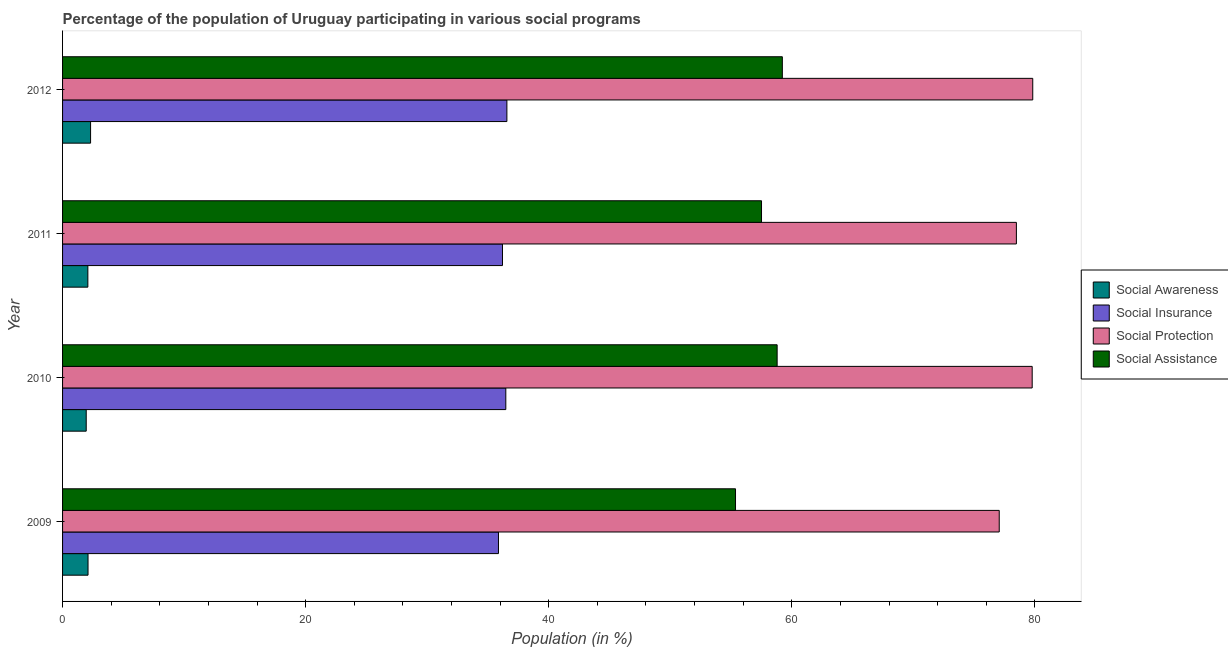How many different coloured bars are there?
Provide a short and direct response. 4. Are the number of bars per tick equal to the number of legend labels?
Your answer should be compact. Yes. In how many cases, is the number of bars for a given year not equal to the number of legend labels?
Make the answer very short. 0. What is the participation of population in social protection programs in 2009?
Offer a terse response. 77.07. Across all years, what is the maximum participation of population in social awareness programs?
Ensure brevity in your answer.  2.31. Across all years, what is the minimum participation of population in social assistance programs?
Make the answer very short. 55.37. In which year was the participation of population in social insurance programs minimum?
Provide a short and direct response. 2009. What is the total participation of population in social protection programs in the graph?
Offer a terse response. 315.14. What is the difference between the participation of population in social insurance programs in 2009 and that in 2012?
Provide a succinct answer. -0.69. What is the difference between the participation of population in social awareness programs in 2010 and the participation of population in social protection programs in 2009?
Offer a terse response. -75.12. What is the average participation of population in social protection programs per year?
Keep it short and to the point. 78.79. In the year 2011, what is the difference between the participation of population in social assistance programs and participation of population in social insurance programs?
Offer a very short reply. 21.31. What is the ratio of the participation of population in social insurance programs in 2009 to that in 2012?
Provide a succinct answer. 0.98. Is the participation of population in social assistance programs in 2010 less than that in 2012?
Give a very brief answer. Yes. What is the difference between the highest and the second highest participation of population in social insurance programs?
Your answer should be compact. 0.09. What is the difference between the highest and the lowest participation of population in social assistance programs?
Your answer should be very brief. 3.85. What does the 2nd bar from the top in 2011 represents?
Your answer should be compact. Social Protection. What does the 3rd bar from the bottom in 2010 represents?
Provide a short and direct response. Social Protection. Is it the case that in every year, the sum of the participation of population in social awareness programs and participation of population in social insurance programs is greater than the participation of population in social protection programs?
Make the answer very short. No. How many years are there in the graph?
Provide a short and direct response. 4. What is the difference between two consecutive major ticks on the X-axis?
Give a very brief answer. 20. Where does the legend appear in the graph?
Your answer should be very brief. Center right. What is the title of the graph?
Ensure brevity in your answer.  Percentage of the population of Uruguay participating in various social programs . Does "Tertiary education" appear as one of the legend labels in the graph?
Make the answer very short. No. What is the label or title of the X-axis?
Provide a succinct answer. Population (in %). What is the label or title of the Y-axis?
Your response must be concise. Year. What is the Population (in %) in Social Awareness in 2009?
Provide a short and direct response. 2.1. What is the Population (in %) of Social Insurance in 2009?
Provide a short and direct response. 35.86. What is the Population (in %) of Social Protection in 2009?
Your answer should be very brief. 77.07. What is the Population (in %) in Social Assistance in 2009?
Offer a terse response. 55.37. What is the Population (in %) of Social Awareness in 2010?
Your response must be concise. 1.95. What is the Population (in %) in Social Insurance in 2010?
Offer a very short reply. 36.47. What is the Population (in %) in Social Protection in 2010?
Your answer should be very brief. 79.78. What is the Population (in %) in Social Assistance in 2010?
Offer a very short reply. 58.79. What is the Population (in %) of Social Awareness in 2011?
Keep it short and to the point. 2.08. What is the Population (in %) in Social Insurance in 2011?
Your answer should be very brief. 36.19. What is the Population (in %) in Social Protection in 2011?
Offer a very short reply. 78.48. What is the Population (in %) of Social Assistance in 2011?
Give a very brief answer. 57.51. What is the Population (in %) of Social Awareness in 2012?
Your response must be concise. 2.31. What is the Population (in %) of Social Insurance in 2012?
Make the answer very short. 36.56. What is the Population (in %) in Social Protection in 2012?
Make the answer very short. 79.82. What is the Population (in %) of Social Assistance in 2012?
Provide a short and direct response. 59.22. Across all years, what is the maximum Population (in %) in Social Awareness?
Offer a very short reply. 2.31. Across all years, what is the maximum Population (in %) in Social Insurance?
Your response must be concise. 36.56. Across all years, what is the maximum Population (in %) in Social Protection?
Keep it short and to the point. 79.82. Across all years, what is the maximum Population (in %) of Social Assistance?
Your answer should be compact. 59.22. Across all years, what is the minimum Population (in %) of Social Awareness?
Give a very brief answer. 1.95. Across all years, what is the minimum Population (in %) of Social Insurance?
Offer a very short reply. 35.86. Across all years, what is the minimum Population (in %) in Social Protection?
Your answer should be compact. 77.07. Across all years, what is the minimum Population (in %) in Social Assistance?
Provide a short and direct response. 55.37. What is the total Population (in %) in Social Awareness in the graph?
Keep it short and to the point. 8.43. What is the total Population (in %) in Social Insurance in the graph?
Ensure brevity in your answer.  145.08. What is the total Population (in %) in Social Protection in the graph?
Keep it short and to the point. 315.14. What is the total Population (in %) in Social Assistance in the graph?
Your answer should be compact. 230.89. What is the difference between the Population (in %) of Social Awareness in 2009 and that in 2010?
Your response must be concise. 0.15. What is the difference between the Population (in %) in Social Insurance in 2009 and that in 2010?
Provide a short and direct response. -0.6. What is the difference between the Population (in %) of Social Protection in 2009 and that in 2010?
Offer a very short reply. -2.71. What is the difference between the Population (in %) in Social Assistance in 2009 and that in 2010?
Your answer should be compact. -3.42. What is the difference between the Population (in %) in Social Awareness in 2009 and that in 2011?
Provide a succinct answer. 0.01. What is the difference between the Population (in %) of Social Insurance in 2009 and that in 2011?
Ensure brevity in your answer.  -0.33. What is the difference between the Population (in %) in Social Protection in 2009 and that in 2011?
Your response must be concise. -1.41. What is the difference between the Population (in %) of Social Assistance in 2009 and that in 2011?
Provide a succinct answer. -2.14. What is the difference between the Population (in %) in Social Awareness in 2009 and that in 2012?
Ensure brevity in your answer.  -0.21. What is the difference between the Population (in %) of Social Insurance in 2009 and that in 2012?
Give a very brief answer. -0.69. What is the difference between the Population (in %) in Social Protection in 2009 and that in 2012?
Provide a succinct answer. -2.76. What is the difference between the Population (in %) in Social Assistance in 2009 and that in 2012?
Your answer should be very brief. -3.85. What is the difference between the Population (in %) of Social Awareness in 2010 and that in 2011?
Your answer should be compact. -0.14. What is the difference between the Population (in %) in Social Insurance in 2010 and that in 2011?
Provide a short and direct response. 0.27. What is the difference between the Population (in %) of Social Protection in 2010 and that in 2011?
Provide a short and direct response. 1.3. What is the difference between the Population (in %) of Social Assistance in 2010 and that in 2011?
Your answer should be compact. 1.28. What is the difference between the Population (in %) of Social Awareness in 2010 and that in 2012?
Your response must be concise. -0.36. What is the difference between the Population (in %) of Social Insurance in 2010 and that in 2012?
Your answer should be compact. -0.09. What is the difference between the Population (in %) of Social Protection in 2010 and that in 2012?
Make the answer very short. -0.05. What is the difference between the Population (in %) of Social Assistance in 2010 and that in 2012?
Provide a short and direct response. -0.43. What is the difference between the Population (in %) of Social Awareness in 2011 and that in 2012?
Your response must be concise. -0.22. What is the difference between the Population (in %) in Social Insurance in 2011 and that in 2012?
Provide a succinct answer. -0.36. What is the difference between the Population (in %) in Social Protection in 2011 and that in 2012?
Provide a short and direct response. -1.35. What is the difference between the Population (in %) of Social Assistance in 2011 and that in 2012?
Provide a succinct answer. -1.71. What is the difference between the Population (in %) in Social Awareness in 2009 and the Population (in %) in Social Insurance in 2010?
Provide a short and direct response. -34.37. What is the difference between the Population (in %) in Social Awareness in 2009 and the Population (in %) in Social Protection in 2010?
Your response must be concise. -77.68. What is the difference between the Population (in %) of Social Awareness in 2009 and the Population (in %) of Social Assistance in 2010?
Offer a very short reply. -56.7. What is the difference between the Population (in %) of Social Insurance in 2009 and the Population (in %) of Social Protection in 2010?
Offer a very short reply. -43.91. What is the difference between the Population (in %) of Social Insurance in 2009 and the Population (in %) of Social Assistance in 2010?
Give a very brief answer. -22.93. What is the difference between the Population (in %) in Social Protection in 2009 and the Population (in %) in Social Assistance in 2010?
Offer a terse response. 18.27. What is the difference between the Population (in %) in Social Awareness in 2009 and the Population (in %) in Social Insurance in 2011?
Give a very brief answer. -34.1. What is the difference between the Population (in %) in Social Awareness in 2009 and the Population (in %) in Social Protection in 2011?
Provide a succinct answer. -76.38. What is the difference between the Population (in %) of Social Awareness in 2009 and the Population (in %) of Social Assistance in 2011?
Make the answer very short. -55.41. What is the difference between the Population (in %) in Social Insurance in 2009 and the Population (in %) in Social Protection in 2011?
Offer a very short reply. -42.61. What is the difference between the Population (in %) in Social Insurance in 2009 and the Population (in %) in Social Assistance in 2011?
Your response must be concise. -21.64. What is the difference between the Population (in %) in Social Protection in 2009 and the Population (in %) in Social Assistance in 2011?
Your answer should be compact. 19.56. What is the difference between the Population (in %) of Social Awareness in 2009 and the Population (in %) of Social Insurance in 2012?
Offer a very short reply. -34.46. What is the difference between the Population (in %) of Social Awareness in 2009 and the Population (in %) of Social Protection in 2012?
Provide a succinct answer. -77.73. What is the difference between the Population (in %) of Social Awareness in 2009 and the Population (in %) of Social Assistance in 2012?
Provide a succinct answer. -57.13. What is the difference between the Population (in %) of Social Insurance in 2009 and the Population (in %) of Social Protection in 2012?
Provide a short and direct response. -43.96. What is the difference between the Population (in %) of Social Insurance in 2009 and the Population (in %) of Social Assistance in 2012?
Your answer should be very brief. -23.36. What is the difference between the Population (in %) of Social Protection in 2009 and the Population (in %) of Social Assistance in 2012?
Your response must be concise. 17.84. What is the difference between the Population (in %) in Social Awareness in 2010 and the Population (in %) in Social Insurance in 2011?
Provide a succinct answer. -34.25. What is the difference between the Population (in %) of Social Awareness in 2010 and the Population (in %) of Social Protection in 2011?
Your response must be concise. -76.53. What is the difference between the Population (in %) in Social Awareness in 2010 and the Population (in %) in Social Assistance in 2011?
Your answer should be compact. -55.56. What is the difference between the Population (in %) of Social Insurance in 2010 and the Population (in %) of Social Protection in 2011?
Offer a terse response. -42.01. What is the difference between the Population (in %) of Social Insurance in 2010 and the Population (in %) of Social Assistance in 2011?
Ensure brevity in your answer.  -21.04. What is the difference between the Population (in %) in Social Protection in 2010 and the Population (in %) in Social Assistance in 2011?
Give a very brief answer. 22.27. What is the difference between the Population (in %) of Social Awareness in 2010 and the Population (in %) of Social Insurance in 2012?
Offer a very short reply. -34.61. What is the difference between the Population (in %) in Social Awareness in 2010 and the Population (in %) in Social Protection in 2012?
Give a very brief answer. -77.88. What is the difference between the Population (in %) of Social Awareness in 2010 and the Population (in %) of Social Assistance in 2012?
Your response must be concise. -57.27. What is the difference between the Population (in %) of Social Insurance in 2010 and the Population (in %) of Social Protection in 2012?
Keep it short and to the point. -43.35. What is the difference between the Population (in %) in Social Insurance in 2010 and the Population (in %) in Social Assistance in 2012?
Your answer should be very brief. -22.75. What is the difference between the Population (in %) in Social Protection in 2010 and the Population (in %) in Social Assistance in 2012?
Ensure brevity in your answer.  20.56. What is the difference between the Population (in %) in Social Awareness in 2011 and the Population (in %) in Social Insurance in 2012?
Make the answer very short. -34.48. What is the difference between the Population (in %) in Social Awareness in 2011 and the Population (in %) in Social Protection in 2012?
Offer a very short reply. -77.74. What is the difference between the Population (in %) in Social Awareness in 2011 and the Population (in %) in Social Assistance in 2012?
Ensure brevity in your answer.  -57.14. What is the difference between the Population (in %) of Social Insurance in 2011 and the Population (in %) of Social Protection in 2012?
Your answer should be very brief. -43.63. What is the difference between the Population (in %) of Social Insurance in 2011 and the Population (in %) of Social Assistance in 2012?
Give a very brief answer. -23.03. What is the difference between the Population (in %) of Social Protection in 2011 and the Population (in %) of Social Assistance in 2012?
Your response must be concise. 19.26. What is the average Population (in %) in Social Awareness per year?
Make the answer very short. 2.11. What is the average Population (in %) of Social Insurance per year?
Offer a very short reply. 36.27. What is the average Population (in %) of Social Protection per year?
Your answer should be very brief. 78.79. What is the average Population (in %) of Social Assistance per year?
Ensure brevity in your answer.  57.72. In the year 2009, what is the difference between the Population (in %) of Social Awareness and Population (in %) of Social Insurance?
Make the answer very short. -33.77. In the year 2009, what is the difference between the Population (in %) of Social Awareness and Population (in %) of Social Protection?
Your answer should be very brief. -74.97. In the year 2009, what is the difference between the Population (in %) in Social Awareness and Population (in %) in Social Assistance?
Keep it short and to the point. -53.27. In the year 2009, what is the difference between the Population (in %) of Social Insurance and Population (in %) of Social Protection?
Provide a succinct answer. -41.2. In the year 2009, what is the difference between the Population (in %) in Social Insurance and Population (in %) in Social Assistance?
Give a very brief answer. -19.5. In the year 2009, what is the difference between the Population (in %) in Social Protection and Population (in %) in Social Assistance?
Provide a succinct answer. 21.7. In the year 2010, what is the difference between the Population (in %) in Social Awareness and Population (in %) in Social Insurance?
Your answer should be very brief. -34.52. In the year 2010, what is the difference between the Population (in %) of Social Awareness and Population (in %) of Social Protection?
Your response must be concise. -77.83. In the year 2010, what is the difference between the Population (in %) of Social Awareness and Population (in %) of Social Assistance?
Give a very brief answer. -56.85. In the year 2010, what is the difference between the Population (in %) in Social Insurance and Population (in %) in Social Protection?
Your response must be concise. -43.31. In the year 2010, what is the difference between the Population (in %) in Social Insurance and Population (in %) in Social Assistance?
Give a very brief answer. -22.32. In the year 2010, what is the difference between the Population (in %) of Social Protection and Population (in %) of Social Assistance?
Your response must be concise. 20.98. In the year 2011, what is the difference between the Population (in %) of Social Awareness and Population (in %) of Social Insurance?
Keep it short and to the point. -34.11. In the year 2011, what is the difference between the Population (in %) of Social Awareness and Population (in %) of Social Protection?
Your answer should be compact. -76.4. In the year 2011, what is the difference between the Population (in %) in Social Awareness and Population (in %) in Social Assistance?
Give a very brief answer. -55.43. In the year 2011, what is the difference between the Population (in %) in Social Insurance and Population (in %) in Social Protection?
Ensure brevity in your answer.  -42.28. In the year 2011, what is the difference between the Population (in %) of Social Insurance and Population (in %) of Social Assistance?
Provide a short and direct response. -21.31. In the year 2011, what is the difference between the Population (in %) in Social Protection and Population (in %) in Social Assistance?
Your answer should be very brief. 20.97. In the year 2012, what is the difference between the Population (in %) in Social Awareness and Population (in %) in Social Insurance?
Offer a very short reply. -34.25. In the year 2012, what is the difference between the Population (in %) of Social Awareness and Population (in %) of Social Protection?
Offer a very short reply. -77.52. In the year 2012, what is the difference between the Population (in %) of Social Awareness and Population (in %) of Social Assistance?
Offer a terse response. -56.92. In the year 2012, what is the difference between the Population (in %) in Social Insurance and Population (in %) in Social Protection?
Your answer should be very brief. -43.27. In the year 2012, what is the difference between the Population (in %) of Social Insurance and Population (in %) of Social Assistance?
Your response must be concise. -22.66. In the year 2012, what is the difference between the Population (in %) in Social Protection and Population (in %) in Social Assistance?
Make the answer very short. 20.6. What is the ratio of the Population (in %) in Social Awareness in 2009 to that in 2010?
Offer a very short reply. 1.08. What is the ratio of the Population (in %) in Social Insurance in 2009 to that in 2010?
Provide a succinct answer. 0.98. What is the ratio of the Population (in %) in Social Protection in 2009 to that in 2010?
Ensure brevity in your answer.  0.97. What is the ratio of the Population (in %) of Social Assistance in 2009 to that in 2010?
Your response must be concise. 0.94. What is the ratio of the Population (in %) in Social Insurance in 2009 to that in 2011?
Your answer should be compact. 0.99. What is the ratio of the Population (in %) in Social Protection in 2009 to that in 2011?
Your answer should be very brief. 0.98. What is the ratio of the Population (in %) of Social Assistance in 2009 to that in 2011?
Provide a short and direct response. 0.96. What is the ratio of the Population (in %) of Social Insurance in 2009 to that in 2012?
Offer a very short reply. 0.98. What is the ratio of the Population (in %) of Social Protection in 2009 to that in 2012?
Your answer should be very brief. 0.97. What is the ratio of the Population (in %) in Social Assistance in 2009 to that in 2012?
Give a very brief answer. 0.93. What is the ratio of the Population (in %) of Social Awareness in 2010 to that in 2011?
Your answer should be very brief. 0.94. What is the ratio of the Population (in %) in Social Insurance in 2010 to that in 2011?
Offer a terse response. 1.01. What is the ratio of the Population (in %) of Social Protection in 2010 to that in 2011?
Ensure brevity in your answer.  1.02. What is the ratio of the Population (in %) in Social Assistance in 2010 to that in 2011?
Keep it short and to the point. 1.02. What is the ratio of the Population (in %) in Social Awareness in 2010 to that in 2012?
Keep it short and to the point. 0.84. What is the ratio of the Population (in %) of Social Assistance in 2010 to that in 2012?
Provide a succinct answer. 0.99. What is the ratio of the Population (in %) in Social Awareness in 2011 to that in 2012?
Ensure brevity in your answer.  0.9. What is the ratio of the Population (in %) of Social Insurance in 2011 to that in 2012?
Your answer should be compact. 0.99. What is the ratio of the Population (in %) of Social Protection in 2011 to that in 2012?
Give a very brief answer. 0.98. What is the ratio of the Population (in %) of Social Assistance in 2011 to that in 2012?
Keep it short and to the point. 0.97. What is the difference between the highest and the second highest Population (in %) of Social Awareness?
Provide a short and direct response. 0.21. What is the difference between the highest and the second highest Population (in %) of Social Insurance?
Your answer should be very brief. 0.09. What is the difference between the highest and the second highest Population (in %) of Social Protection?
Provide a short and direct response. 0.05. What is the difference between the highest and the second highest Population (in %) of Social Assistance?
Make the answer very short. 0.43. What is the difference between the highest and the lowest Population (in %) in Social Awareness?
Your answer should be very brief. 0.36. What is the difference between the highest and the lowest Population (in %) in Social Insurance?
Your answer should be compact. 0.69. What is the difference between the highest and the lowest Population (in %) in Social Protection?
Ensure brevity in your answer.  2.76. What is the difference between the highest and the lowest Population (in %) in Social Assistance?
Your response must be concise. 3.85. 